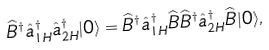<formula> <loc_0><loc_0><loc_500><loc_500>\widehat { B } ^ { \dagger } \hat { a } ^ { \dagger } _ { 1 H } \hat { a } ^ { \dagger } _ { 2 H } | 0 \rangle = \widehat { B } ^ { \dagger } \hat { a } ^ { \dagger } _ { 1 H } \widehat { B } \widehat { B } ^ { \dagger } \hat { a } ^ { \dagger } _ { 2 H } \widehat { B } | 0 \rangle ,</formula> 